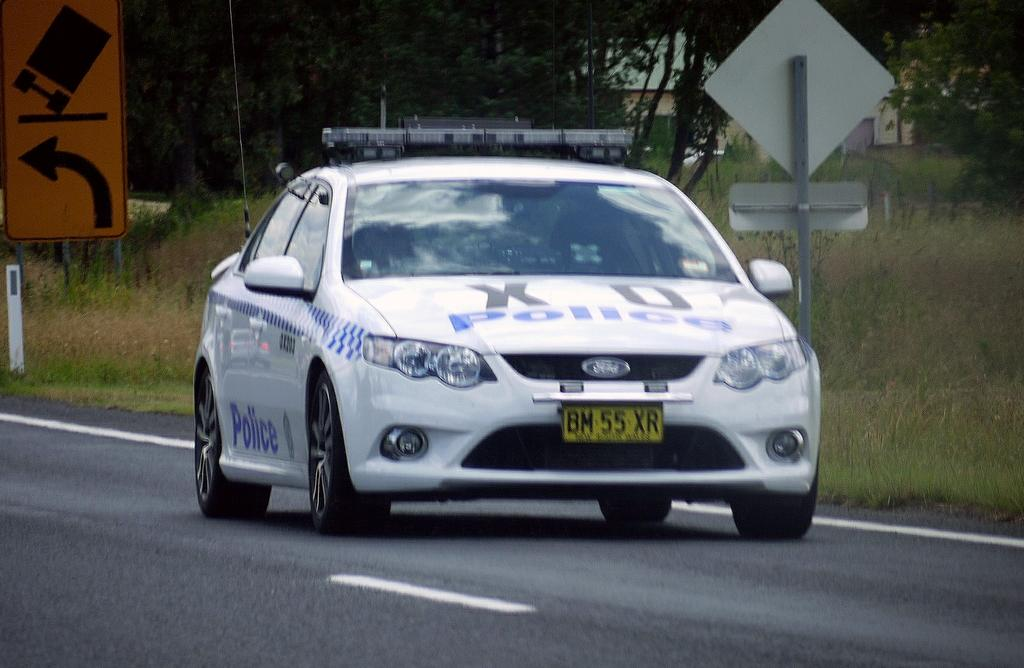What is the main subject of the image? There is a vehicle in the image. What is the setting of the image? The image features a road, ground with grass, plants, trees, poles, sign boards, and buildings. Can you describe the environment in the image? The image shows a combination of natural elements, such as grass, plants, and trees, as well as man-made structures like poles, sign boards, and buildings. What type of bean is growing on the vehicle in the image? There are no beans present in the image, and the vehicle is not a place where beans would typically grow. 